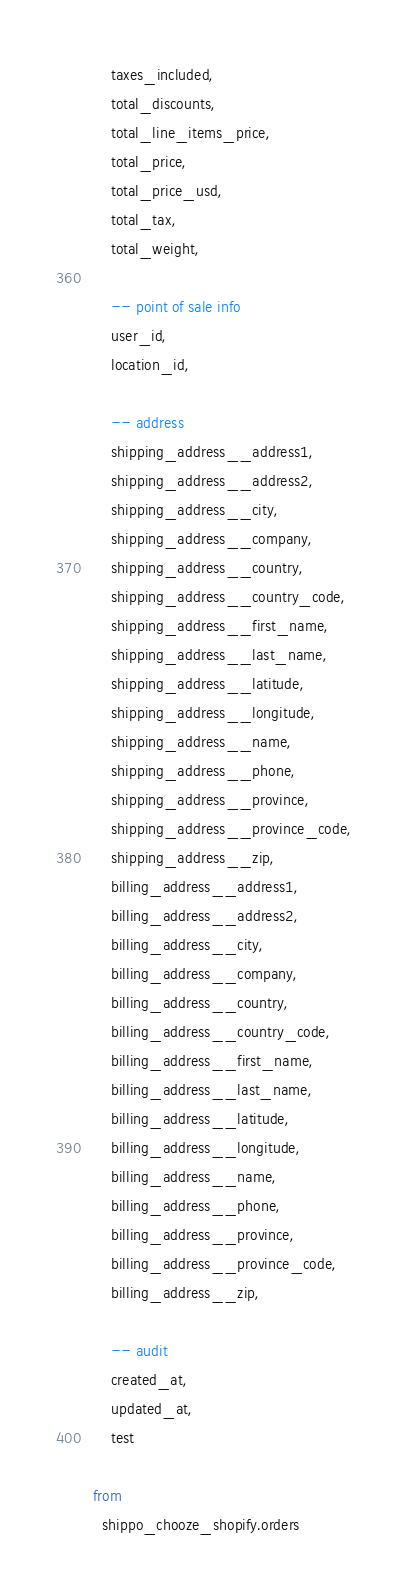<code> <loc_0><loc_0><loc_500><loc_500><_SQL_>    taxes_included,
    total_discounts,
    total_line_items_price,
    total_price,
    total_price_usd,
    total_tax,
    total_weight,

    -- point of sale info
    user_id,
    location_id,

    -- address
    shipping_address__address1,
    shipping_address__address2,
    shipping_address__city,
    shipping_address__company,
    shipping_address__country,
    shipping_address__country_code,
    shipping_address__first_name,
    shipping_address__last_name,
    shipping_address__latitude,
    shipping_address__longitude,
    shipping_address__name,
    shipping_address__phone,
    shipping_address__province,
    shipping_address__province_code,
    shipping_address__zip,
    billing_address__address1,
    billing_address__address2,
    billing_address__city,
    billing_address__company,
    billing_address__country,
    billing_address__country_code,
    billing_address__first_name,
    billing_address__last_name,
    billing_address__latitude,
    billing_address__longitude,
    billing_address__name,
    billing_address__phone,
    billing_address__province,
    billing_address__province_code,
    billing_address__zip,

    -- audit
    created_at,
    updated_at,
    test

from
  shippo_chooze_shopify.orders
</code> 